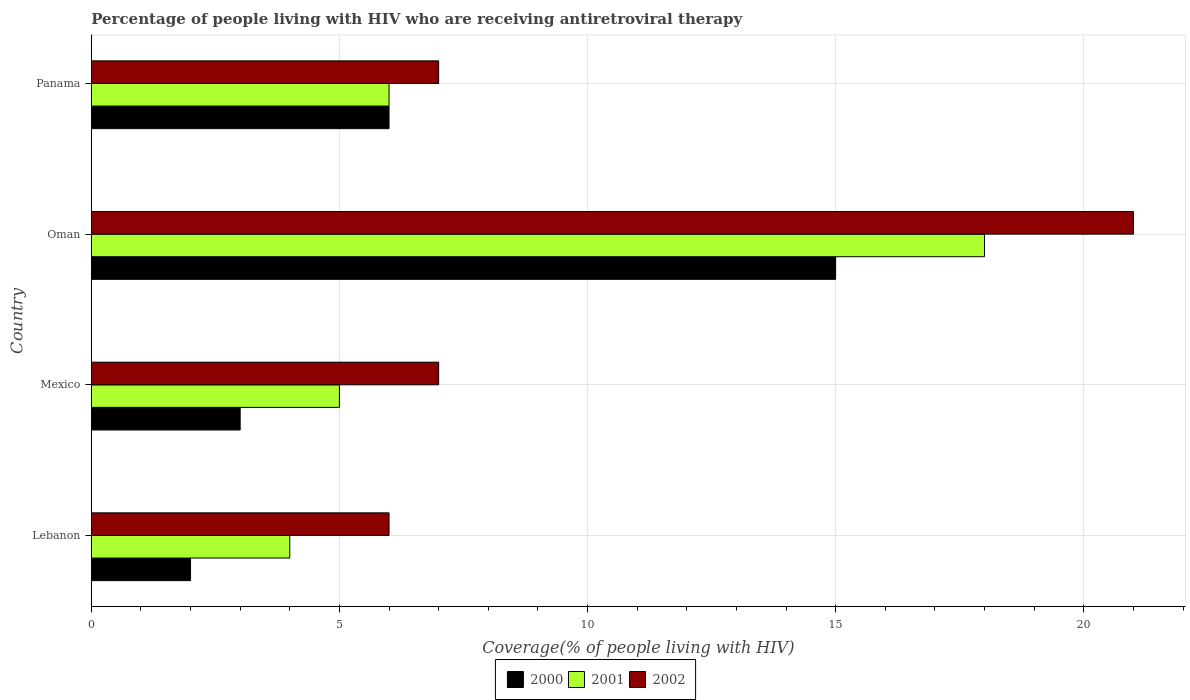How many different coloured bars are there?
Provide a succinct answer. 3. Are the number of bars per tick equal to the number of legend labels?
Offer a very short reply. Yes. How many bars are there on the 2nd tick from the top?
Your answer should be very brief. 3. How many bars are there on the 4th tick from the bottom?
Provide a short and direct response. 3. What is the label of the 3rd group of bars from the top?
Keep it short and to the point. Mexico. In how many cases, is the number of bars for a given country not equal to the number of legend labels?
Keep it short and to the point. 0. Across all countries, what is the minimum percentage of the HIV infected people who are receiving antiretroviral therapy in 2001?
Give a very brief answer. 4. In which country was the percentage of the HIV infected people who are receiving antiretroviral therapy in 2000 maximum?
Your response must be concise. Oman. In which country was the percentage of the HIV infected people who are receiving antiretroviral therapy in 2000 minimum?
Keep it short and to the point. Lebanon. What is the difference between the percentage of the HIV infected people who are receiving antiretroviral therapy in 2001 in Mexico and that in Oman?
Give a very brief answer. -13. What is the average percentage of the HIV infected people who are receiving antiretroviral therapy in 2001 per country?
Make the answer very short. 8.25. What is the difference between the percentage of the HIV infected people who are receiving antiretroviral therapy in 2000 and percentage of the HIV infected people who are receiving antiretroviral therapy in 2001 in Mexico?
Provide a short and direct response. -2. In how many countries, is the percentage of the HIV infected people who are receiving antiretroviral therapy in 2001 greater than 13 %?
Offer a terse response. 1. What is the difference between the highest and the second highest percentage of the HIV infected people who are receiving antiretroviral therapy in 2001?
Provide a succinct answer. 12. In how many countries, is the percentage of the HIV infected people who are receiving antiretroviral therapy in 2002 greater than the average percentage of the HIV infected people who are receiving antiretroviral therapy in 2002 taken over all countries?
Ensure brevity in your answer.  1. What does the 2nd bar from the bottom in Panama represents?
Make the answer very short. 2001. How many countries are there in the graph?
Provide a short and direct response. 4. What is the difference between two consecutive major ticks on the X-axis?
Offer a very short reply. 5. Does the graph contain any zero values?
Offer a very short reply. No. Does the graph contain grids?
Offer a terse response. Yes. What is the title of the graph?
Your answer should be compact. Percentage of people living with HIV who are receiving antiretroviral therapy. What is the label or title of the X-axis?
Provide a short and direct response. Coverage(% of people living with HIV). What is the label or title of the Y-axis?
Offer a very short reply. Country. What is the Coverage(% of people living with HIV) in 2001 in Lebanon?
Your answer should be very brief. 4. What is the Coverage(% of people living with HIV) of 2002 in Lebanon?
Your response must be concise. 6. What is the Coverage(% of people living with HIV) in 2000 in Mexico?
Offer a terse response. 3. What is the Coverage(% of people living with HIV) in 2002 in Mexico?
Provide a short and direct response. 7. What is the Coverage(% of people living with HIV) of 2002 in Oman?
Your answer should be very brief. 21. What is the Coverage(% of people living with HIV) in 2000 in Panama?
Make the answer very short. 6. What is the Coverage(% of people living with HIV) in 2002 in Panama?
Keep it short and to the point. 7. Across all countries, what is the maximum Coverage(% of people living with HIV) in 2002?
Your response must be concise. 21. Across all countries, what is the minimum Coverage(% of people living with HIV) of 2000?
Keep it short and to the point. 2. Across all countries, what is the minimum Coverage(% of people living with HIV) in 2001?
Make the answer very short. 4. What is the total Coverage(% of people living with HIV) in 2001 in the graph?
Provide a short and direct response. 33. What is the difference between the Coverage(% of people living with HIV) in 2000 in Lebanon and that in Mexico?
Provide a short and direct response. -1. What is the difference between the Coverage(% of people living with HIV) of 2000 in Lebanon and that in Oman?
Provide a succinct answer. -13. What is the difference between the Coverage(% of people living with HIV) in 2001 in Lebanon and that in Oman?
Your answer should be compact. -14. What is the difference between the Coverage(% of people living with HIV) of 2002 in Lebanon and that in Oman?
Your response must be concise. -15. What is the difference between the Coverage(% of people living with HIV) of 2001 in Lebanon and that in Panama?
Offer a terse response. -2. What is the difference between the Coverage(% of people living with HIV) of 2000 in Mexico and that in Oman?
Give a very brief answer. -12. What is the difference between the Coverage(% of people living with HIV) of 2001 in Mexico and that in Oman?
Your answer should be very brief. -13. What is the difference between the Coverage(% of people living with HIV) of 2002 in Mexico and that in Panama?
Your answer should be compact. 0. What is the difference between the Coverage(% of people living with HIV) of 2001 in Oman and that in Panama?
Give a very brief answer. 12. What is the difference between the Coverage(% of people living with HIV) of 2000 in Lebanon and the Coverage(% of people living with HIV) of 2001 in Mexico?
Your answer should be very brief. -3. What is the difference between the Coverage(% of people living with HIV) in 2001 in Lebanon and the Coverage(% of people living with HIV) in 2002 in Oman?
Ensure brevity in your answer.  -17. What is the difference between the Coverage(% of people living with HIV) of 2000 in Lebanon and the Coverage(% of people living with HIV) of 2002 in Panama?
Your answer should be very brief. -5. What is the difference between the Coverage(% of people living with HIV) of 2000 in Mexico and the Coverage(% of people living with HIV) of 2001 in Oman?
Provide a short and direct response. -15. What is the difference between the Coverage(% of people living with HIV) of 2000 in Mexico and the Coverage(% of people living with HIV) of 2002 in Oman?
Ensure brevity in your answer.  -18. What is the difference between the Coverage(% of people living with HIV) in 2000 in Mexico and the Coverage(% of people living with HIV) in 2001 in Panama?
Ensure brevity in your answer.  -3. What is the difference between the Coverage(% of people living with HIV) of 2001 in Mexico and the Coverage(% of people living with HIV) of 2002 in Panama?
Offer a terse response. -2. What is the difference between the Coverage(% of people living with HIV) of 2000 in Oman and the Coverage(% of people living with HIV) of 2001 in Panama?
Provide a succinct answer. 9. What is the difference between the Coverage(% of people living with HIV) in 2000 in Oman and the Coverage(% of people living with HIV) in 2002 in Panama?
Your answer should be compact. 8. What is the average Coverage(% of people living with HIV) in 2001 per country?
Keep it short and to the point. 8.25. What is the average Coverage(% of people living with HIV) of 2002 per country?
Provide a succinct answer. 10.25. What is the difference between the Coverage(% of people living with HIV) in 2000 and Coverage(% of people living with HIV) in 2001 in Lebanon?
Your answer should be very brief. -2. What is the difference between the Coverage(% of people living with HIV) in 2001 and Coverage(% of people living with HIV) in 2002 in Lebanon?
Give a very brief answer. -2. What is the difference between the Coverage(% of people living with HIV) of 2000 and Coverage(% of people living with HIV) of 2001 in Mexico?
Provide a succinct answer. -2. What is the difference between the Coverage(% of people living with HIV) in 2001 and Coverage(% of people living with HIV) in 2002 in Mexico?
Your answer should be very brief. -2. What is the difference between the Coverage(% of people living with HIV) in 2000 and Coverage(% of people living with HIV) in 2002 in Oman?
Give a very brief answer. -6. What is the difference between the Coverage(% of people living with HIV) in 2000 and Coverage(% of people living with HIV) in 2001 in Panama?
Offer a very short reply. 0. What is the difference between the Coverage(% of people living with HIV) of 2000 and Coverage(% of people living with HIV) of 2002 in Panama?
Your answer should be very brief. -1. What is the ratio of the Coverage(% of people living with HIV) in 2000 in Lebanon to that in Mexico?
Keep it short and to the point. 0.67. What is the ratio of the Coverage(% of people living with HIV) of 2001 in Lebanon to that in Mexico?
Your response must be concise. 0.8. What is the ratio of the Coverage(% of people living with HIV) of 2000 in Lebanon to that in Oman?
Provide a short and direct response. 0.13. What is the ratio of the Coverage(% of people living with HIV) in 2001 in Lebanon to that in Oman?
Give a very brief answer. 0.22. What is the ratio of the Coverage(% of people living with HIV) of 2002 in Lebanon to that in Oman?
Give a very brief answer. 0.29. What is the ratio of the Coverage(% of people living with HIV) in 2001 in Lebanon to that in Panama?
Your response must be concise. 0.67. What is the ratio of the Coverage(% of people living with HIV) of 2001 in Mexico to that in Oman?
Make the answer very short. 0.28. What is the ratio of the Coverage(% of people living with HIV) of 2000 in Mexico to that in Panama?
Provide a short and direct response. 0.5. What is the ratio of the Coverage(% of people living with HIV) of 2002 in Mexico to that in Panama?
Provide a succinct answer. 1. What is the ratio of the Coverage(% of people living with HIV) in 2001 in Oman to that in Panama?
Your answer should be compact. 3. What is the difference between the highest and the second highest Coverage(% of people living with HIV) of 2000?
Ensure brevity in your answer.  9. What is the difference between the highest and the second highest Coverage(% of people living with HIV) of 2002?
Offer a terse response. 14. What is the difference between the highest and the lowest Coverage(% of people living with HIV) in 2001?
Offer a very short reply. 14. What is the difference between the highest and the lowest Coverage(% of people living with HIV) in 2002?
Your response must be concise. 15. 